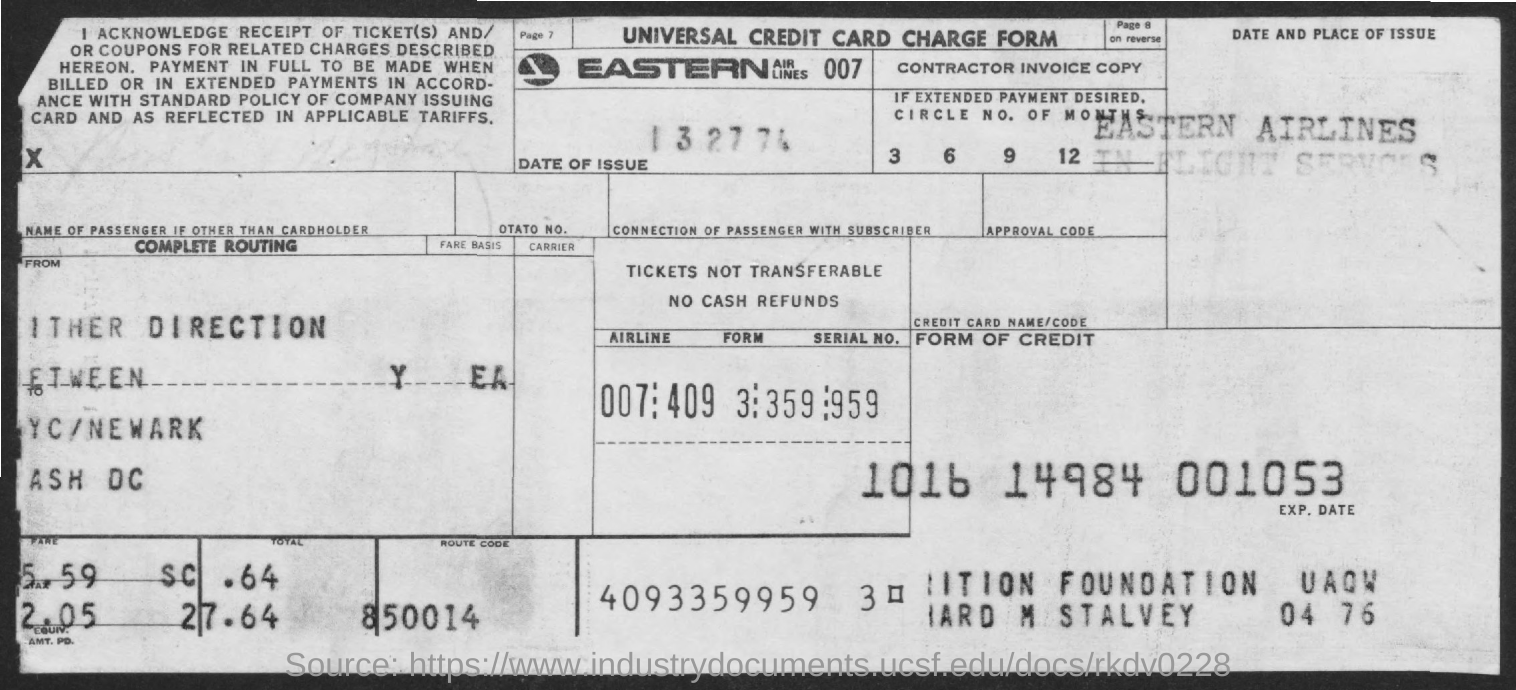What is this form known as?
Offer a terse response. Universal credit card charge form. What is the route code?
Provide a short and direct response. 850014. 